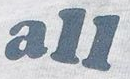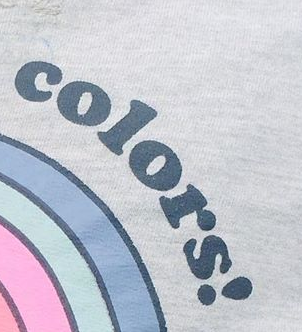What words are shown in these images in order, separated by a semicolon? all; colors! 